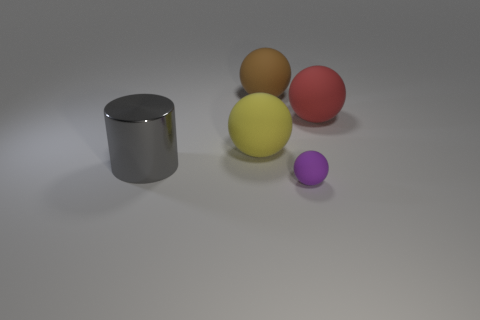Subtract all red balls. How many balls are left? 3 Subtract all large brown balls. How many balls are left? 3 Add 1 purple rubber things. How many objects exist? 6 Subtract all cyan balls. Subtract all blue blocks. How many balls are left? 4 Subtract all cylinders. How many objects are left? 4 Subtract all big yellow spheres. Subtract all brown spheres. How many objects are left? 3 Add 2 big rubber spheres. How many big rubber spheres are left? 5 Add 5 big spheres. How many big spheres exist? 8 Subtract 1 brown balls. How many objects are left? 4 